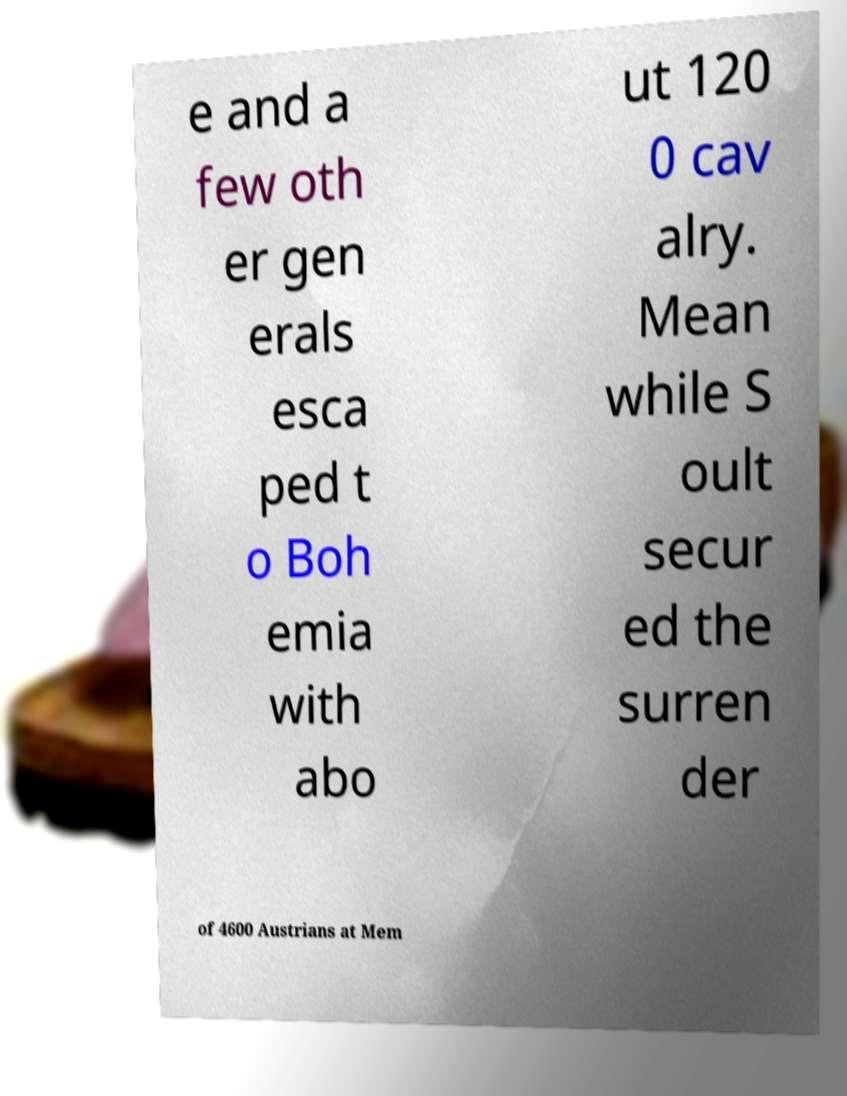Can you accurately transcribe the text from the provided image for me? e and a few oth er gen erals esca ped t o Boh emia with abo ut 120 0 cav alry. Mean while S oult secur ed the surren der of 4600 Austrians at Mem 